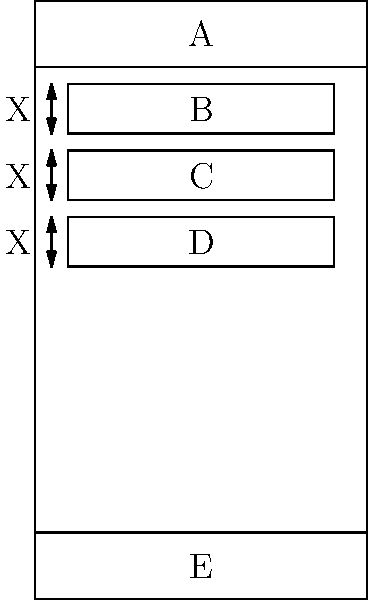In the mobile app wireframe shown above, what design principle is being demonstrated by the consistent spacing (labeled X) between content elements B, C, and D? How does this principle contribute to the overall user experience? To answer this question, let's break down the key elements and principles at play:

1. Observation: The wireframe shows three content elements (B, C, and D) with equal spacing between them, labeled as X.

2. Design Principle: This demonstrates the principle of consistent spacing, also known as uniform spacing or rhythmic spacing.

3. Purpose of Consistent Spacing:
   a) Creates visual harmony and balance in the design
   b) Improves readability and scannability of content
   c) Establishes a clear visual hierarchy
   d) Guides the user's eye through the content in a logical flow

4. Impact on User Experience:
   a) Enhances aesthetic appeal, making the app more visually pleasing
   b) Reduces cognitive load by presenting information in an organized manner
   c) Improves usability by making content easier to navigate and understand
   d) Creates a sense of professionalism and attention to detail

5. Relation to other UI elements:
   a) The consistent spacing complements the aligned left edges of the content blocks
   b) It creates a clear separation from the header (A) and footer (E) elements

In conclusion, the consistent spacing demonstrates the principle of rhythm in design, which significantly contributes to a better user experience by improving readability, organization, and overall visual appeal of the mobile app interface.
Answer: Consistent spacing (rhythm), improving readability and visual organization 